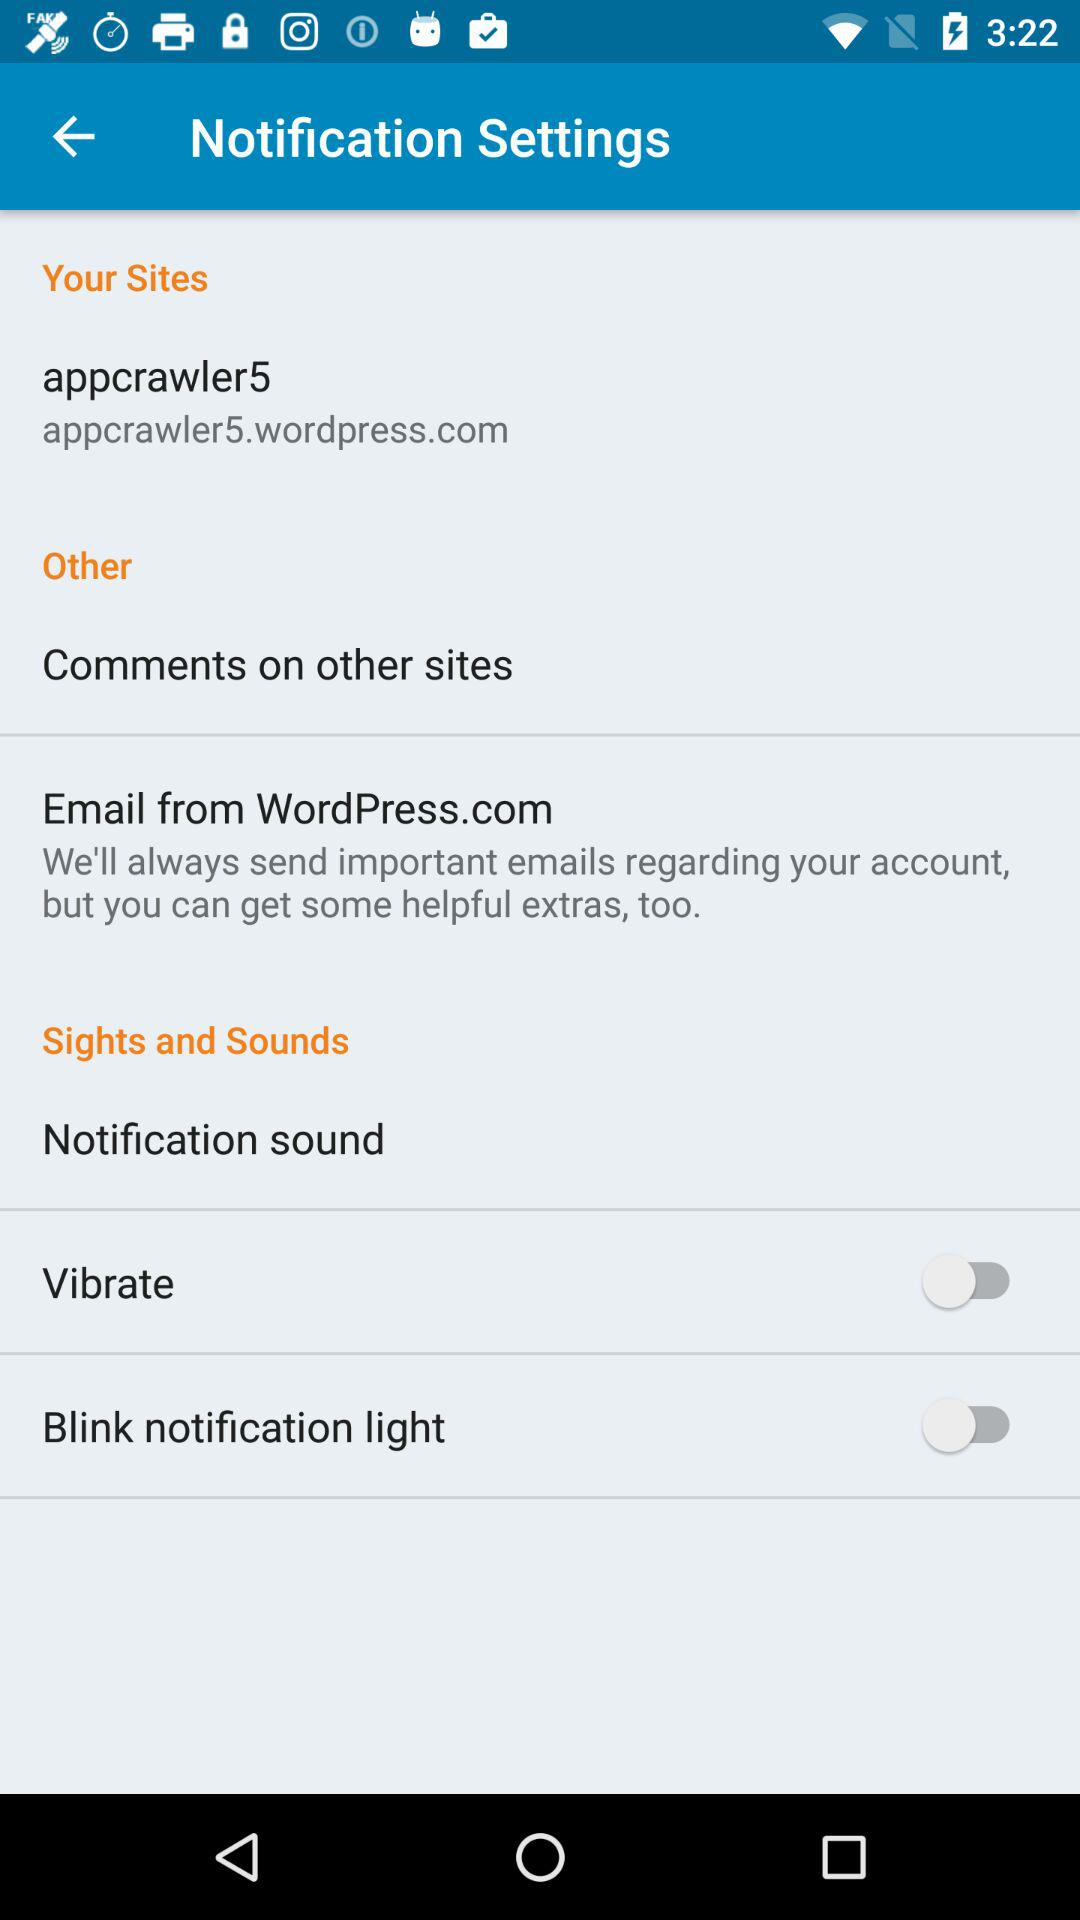What is the user name? The user name is appcrawler5. 